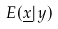<formula> <loc_0><loc_0><loc_500><loc_500>E ( \underline { x } | y )</formula> 